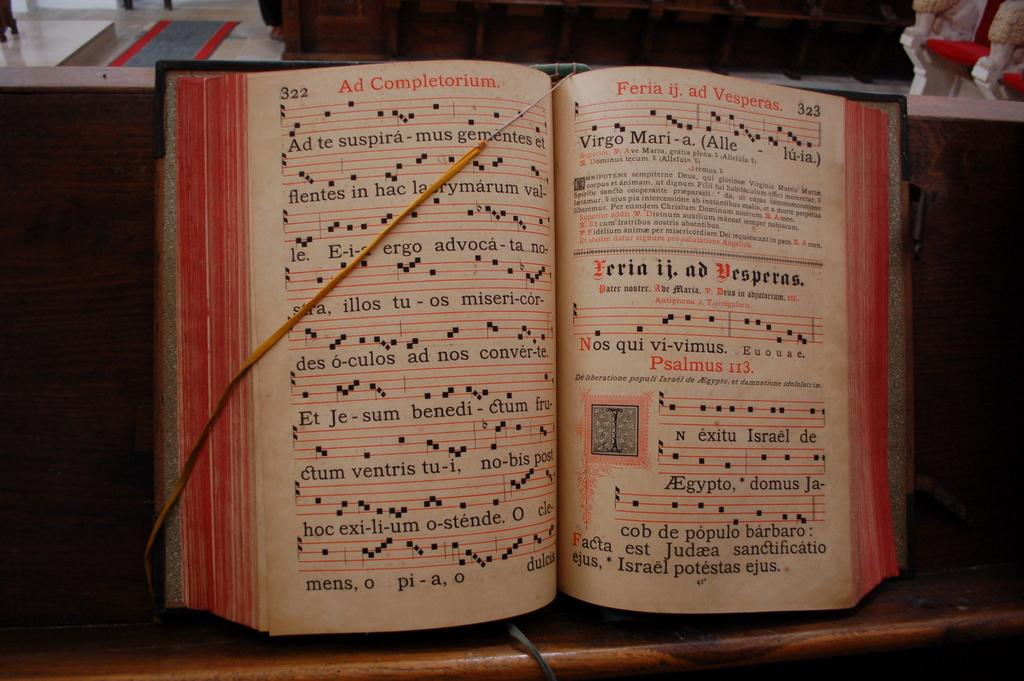<image>
Present a compact description of the photo's key features. A book that is opened to pages titled Ad Complementorium and Feria ij. ad Vesperas. 